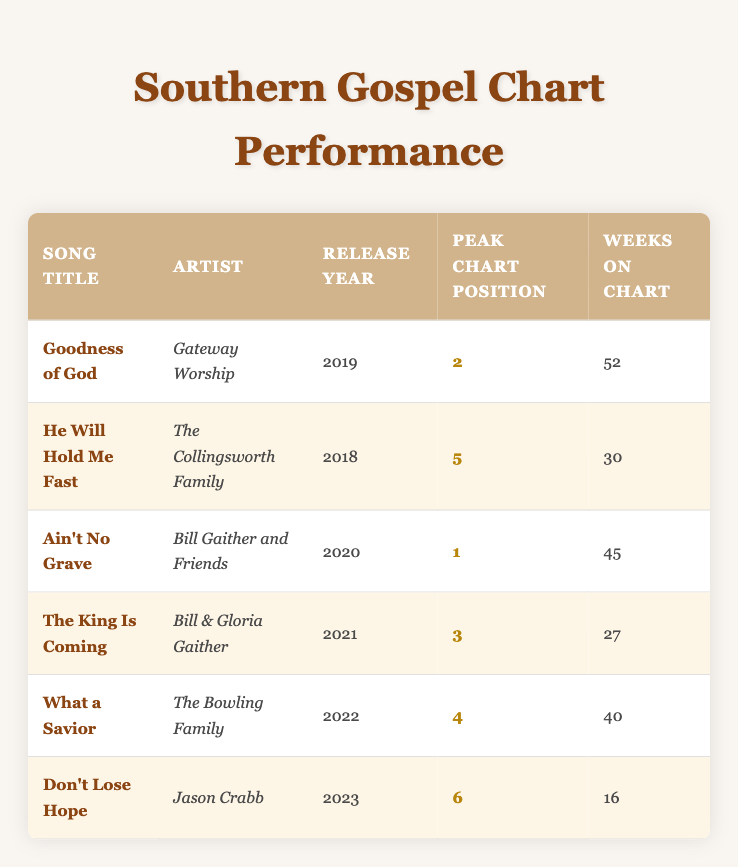What is the Peak Chart Position of "Goodness of God"? The table shows that "Goodness of God" by Gateway Worship peaked at position 2.
Answer: 2 Which song had the longest duration on the chart? By looking at the "Weeks On Chart" column, "Goodness of God" has the highest value with 52 weeks.
Answer: Goodness of God How many songs were released in 2020? Referring to the "Release Year" column, there is one song, "Ain't No Grave" by Bill Gaither and Friends, released in 2020.
Answer: 1 What is the average Peak Chart Position of the songs listed? The Peak Chart Positions are 2, 5, 1, 3, 4, and 6. Adding them all gives 21, and there are 6 songs, so the average is 21/6 ≈ 3.5.
Answer: 3.5 Did any song release since 2021 reach a peak position in the top 3? The songs released since 2021 are "The King Is Coming" (3), "What a Savior" (4), and "Don't Lose Hope" (6). Only "The King Is Coming" peaked in the top 3.
Answer: Yes Which artist has a song that peaked at position 1? The table indicates that "Ain't No Grave" by Bill Gaither and Friends peaked at position 1.
Answer: Bill Gaither and Friends How many weeks in total did all songs spend on the chart? Summing the "Weeks On Chart" values: 52 + 30 + 45 + 27 + 40 + 16 equals 210 weeks total.
Answer: 210 Which two songs had a Peak Chart Position of 4 or lower? The songs "Goodness of God" (2), "Ain't No Grave" (1), "The King Is Coming" (3), and "What a Savior" (4) all have positions of 4 or lower.
Answer: Goodness of God, Ain't No Grave, The King Is Coming, What a Savior How many songs reached their peak position within the year of their release? Only "Ain't No Grave" peaked at position 1 in the same year it was released (2020).
Answer: 1 